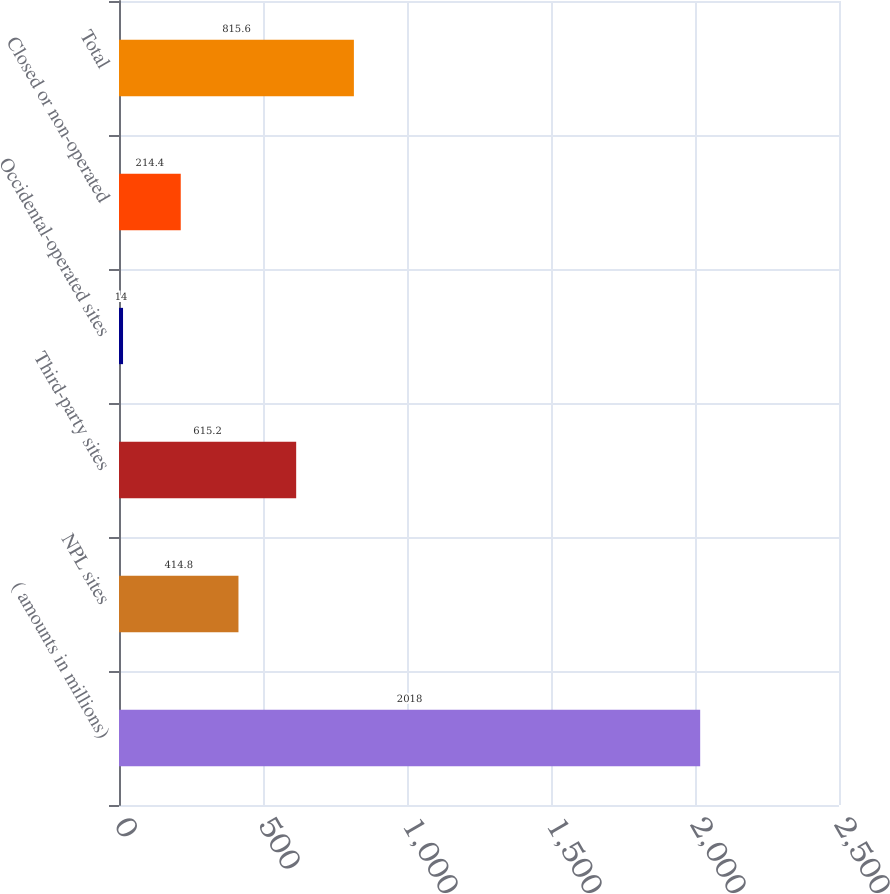<chart> <loc_0><loc_0><loc_500><loc_500><bar_chart><fcel>( amounts in millions)<fcel>NPL sites<fcel>Third-party sites<fcel>Occidental-operated sites<fcel>Closed or non-operated<fcel>Total<nl><fcel>2018<fcel>414.8<fcel>615.2<fcel>14<fcel>214.4<fcel>815.6<nl></chart> 